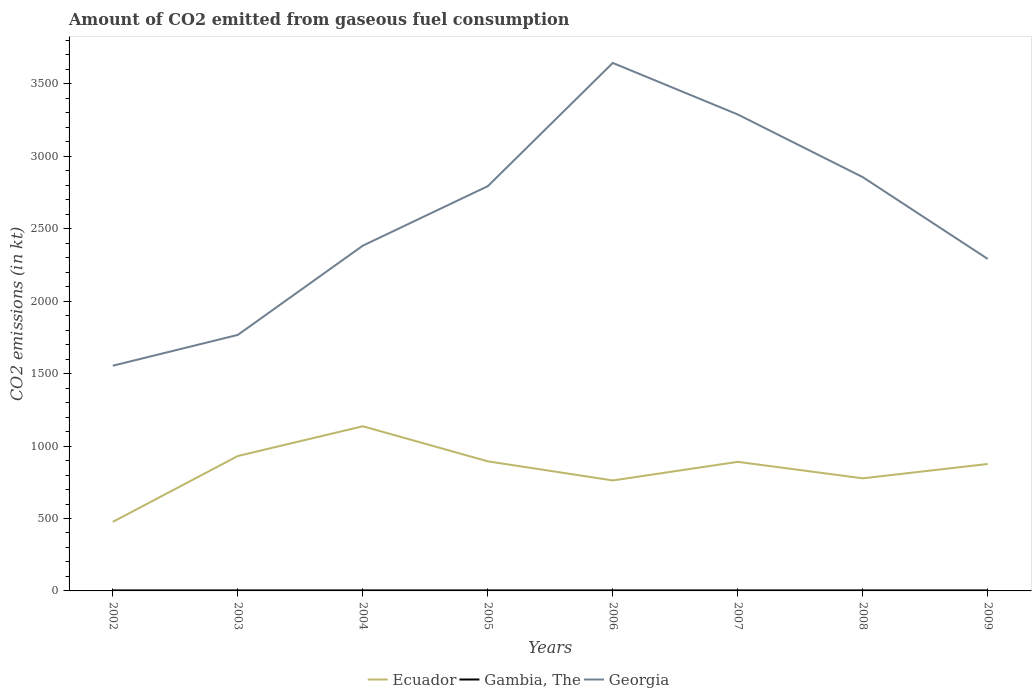How many different coloured lines are there?
Offer a very short reply. 3. Is the number of lines equal to the number of legend labels?
Make the answer very short. Yes. Across all years, what is the maximum amount of CO2 emitted in Gambia, The?
Offer a terse response. 3.67. What is the total amount of CO2 emitted in Ecuador in the graph?
Your response must be concise. 154.01. What is the difference between the highest and the second highest amount of CO2 emitted in Georgia?
Provide a succinct answer. 2090.19. How many lines are there?
Offer a terse response. 3. How many years are there in the graph?
Provide a short and direct response. 8. What is the difference between two consecutive major ticks on the Y-axis?
Your answer should be very brief. 500. Does the graph contain any zero values?
Make the answer very short. No. Where does the legend appear in the graph?
Give a very brief answer. Bottom center. What is the title of the graph?
Provide a short and direct response. Amount of CO2 emitted from gaseous fuel consumption. What is the label or title of the X-axis?
Keep it short and to the point. Years. What is the label or title of the Y-axis?
Your answer should be compact. CO2 emissions (in kt). What is the CO2 emissions (in kt) in Ecuador in 2002?
Give a very brief answer. 476.71. What is the CO2 emissions (in kt) of Gambia, The in 2002?
Give a very brief answer. 3.67. What is the CO2 emissions (in kt) of Georgia in 2002?
Offer a terse response. 1554.81. What is the CO2 emissions (in kt) in Ecuador in 2003?
Offer a very short reply. 931.42. What is the CO2 emissions (in kt) in Gambia, The in 2003?
Make the answer very short. 3.67. What is the CO2 emissions (in kt) of Georgia in 2003?
Provide a short and direct response. 1767.49. What is the CO2 emissions (in kt) in Ecuador in 2004?
Make the answer very short. 1136.77. What is the CO2 emissions (in kt) of Gambia, The in 2004?
Give a very brief answer. 3.67. What is the CO2 emissions (in kt) in Georgia in 2004?
Keep it short and to the point. 2383.55. What is the CO2 emissions (in kt) of Ecuador in 2005?
Provide a succinct answer. 894.75. What is the CO2 emissions (in kt) of Gambia, The in 2005?
Provide a short and direct response. 3.67. What is the CO2 emissions (in kt) in Georgia in 2005?
Offer a terse response. 2794.25. What is the CO2 emissions (in kt) of Ecuador in 2006?
Offer a terse response. 762.74. What is the CO2 emissions (in kt) in Gambia, The in 2006?
Offer a terse response. 3.67. What is the CO2 emissions (in kt) in Georgia in 2006?
Offer a terse response. 3645. What is the CO2 emissions (in kt) of Ecuador in 2007?
Provide a short and direct response. 891.08. What is the CO2 emissions (in kt) of Gambia, The in 2007?
Make the answer very short. 3.67. What is the CO2 emissions (in kt) in Georgia in 2007?
Provide a short and direct response. 3289.3. What is the CO2 emissions (in kt) in Ecuador in 2008?
Keep it short and to the point. 777.4. What is the CO2 emissions (in kt) of Gambia, The in 2008?
Offer a terse response. 3.67. What is the CO2 emissions (in kt) of Georgia in 2008?
Give a very brief answer. 2856.59. What is the CO2 emissions (in kt) in Ecuador in 2009?
Give a very brief answer. 876.41. What is the CO2 emissions (in kt) of Gambia, The in 2009?
Offer a terse response. 3.67. What is the CO2 emissions (in kt) in Georgia in 2009?
Give a very brief answer. 2291.88. Across all years, what is the maximum CO2 emissions (in kt) in Ecuador?
Offer a very short reply. 1136.77. Across all years, what is the maximum CO2 emissions (in kt) of Gambia, The?
Ensure brevity in your answer.  3.67. Across all years, what is the maximum CO2 emissions (in kt) of Georgia?
Make the answer very short. 3645. Across all years, what is the minimum CO2 emissions (in kt) in Ecuador?
Your response must be concise. 476.71. Across all years, what is the minimum CO2 emissions (in kt) of Gambia, The?
Keep it short and to the point. 3.67. Across all years, what is the minimum CO2 emissions (in kt) of Georgia?
Ensure brevity in your answer.  1554.81. What is the total CO2 emissions (in kt) in Ecuador in the graph?
Offer a very short reply. 6747.28. What is the total CO2 emissions (in kt) in Gambia, The in the graph?
Make the answer very short. 29.34. What is the total CO2 emissions (in kt) of Georgia in the graph?
Keep it short and to the point. 2.06e+04. What is the difference between the CO2 emissions (in kt) of Ecuador in 2002 and that in 2003?
Offer a very short reply. -454.71. What is the difference between the CO2 emissions (in kt) in Gambia, The in 2002 and that in 2003?
Your answer should be compact. 0. What is the difference between the CO2 emissions (in kt) of Georgia in 2002 and that in 2003?
Provide a short and direct response. -212.69. What is the difference between the CO2 emissions (in kt) of Ecuador in 2002 and that in 2004?
Your answer should be compact. -660.06. What is the difference between the CO2 emissions (in kt) of Georgia in 2002 and that in 2004?
Give a very brief answer. -828.74. What is the difference between the CO2 emissions (in kt) of Ecuador in 2002 and that in 2005?
Ensure brevity in your answer.  -418.04. What is the difference between the CO2 emissions (in kt) in Gambia, The in 2002 and that in 2005?
Make the answer very short. 0. What is the difference between the CO2 emissions (in kt) of Georgia in 2002 and that in 2005?
Offer a terse response. -1239.45. What is the difference between the CO2 emissions (in kt) of Ecuador in 2002 and that in 2006?
Provide a short and direct response. -286.03. What is the difference between the CO2 emissions (in kt) of Georgia in 2002 and that in 2006?
Your answer should be very brief. -2090.19. What is the difference between the CO2 emissions (in kt) in Ecuador in 2002 and that in 2007?
Your response must be concise. -414.37. What is the difference between the CO2 emissions (in kt) in Georgia in 2002 and that in 2007?
Your response must be concise. -1734.49. What is the difference between the CO2 emissions (in kt) of Ecuador in 2002 and that in 2008?
Your response must be concise. -300.69. What is the difference between the CO2 emissions (in kt) in Gambia, The in 2002 and that in 2008?
Offer a very short reply. 0. What is the difference between the CO2 emissions (in kt) of Georgia in 2002 and that in 2008?
Your response must be concise. -1301.79. What is the difference between the CO2 emissions (in kt) in Ecuador in 2002 and that in 2009?
Offer a terse response. -399.7. What is the difference between the CO2 emissions (in kt) of Georgia in 2002 and that in 2009?
Offer a terse response. -737.07. What is the difference between the CO2 emissions (in kt) in Ecuador in 2003 and that in 2004?
Offer a very short reply. -205.35. What is the difference between the CO2 emissions (in kt) of Gambia, The in 2003 and that in 2004?
Provide a short and direct response. 0. What is the difference between the CO2 emissions (in kt) in Georgia in 2003 and that in 2004?
Your answer should be very brief. -616.06. What is the difference between the CO2 emissions (in kt) of Ecuador in 2003 and that in 2005?
Provide a succinct answer. 36.67. What is the difference between the CO2 emissions (in kt) of Gambia, The in 2003 and that in 2005?
Provide a short and direct response. 0. What is the difference between the CO2 emissions (in kt) of Georgia in 2003 and that in 2005?
Your answer should be very brief. -1026.76. What is the difference between the CO2 emissions (in kt) of Ecuador in 2003 and that in 2006?
Offer a terse response. 168.68. What is the difference between the CO2 emissions (in kt) in Georgia in 2003 and that in 2006?
Your response must be concise. -1877.5. What is the difference between the CO2 emissions (in kt) of Ecuador in 2003 and that in 2007?
Offer a terse response. 40.34. What is the difference between the CO2 emissions (in kt) of Georgia in 2003 and that in 2007?
Your response must be concise. -1521.81. What is the difference between the CO2 emissions (in kt) in Ecuador in 2003 and that in 2008?
Your response must be concise. 154.01. What is the difference between the CO2 emissions (in kt) in Gambia, The in 2003 and that in 2008?
Give a very brief answer. 0. What is the difference between the CO2 emissions (in kt) of Georgia in 2003 and that in 2008?
Offer a very short reply. -1089.1. What is the difference between the CO2 emissions (in kt) of Ecuador in 2003 and that in 2009?
Your answer should be compact. 55.01. What is the difference between the CO2 emissions (in kt) in Georgia in 2003 and that in 2009?
Your answer should be compact. -524.38. What is the difference between the CO2 emissions (in kt) in Ecuador in 2004 and that in 2005?
Your answer should be compact. 242.02. What is the difference between the CO2 emissions (in kt) in Georgia in 2004 and that in 2005?
Offer a very short reply. -410.7. What is the difference between the CO2 emissions (in kt) of Ecuador in 2004 and that in 2006?
Keep it short and to the point. 374.03. What is the difference between the CO2 emissions (in kt) of Gambia, The in 2004 and that in 2006?
Give a very brief answer. 0. What is the difference between the CO2 emissions (in kt) of Georgia in 2004 and that in 2006?
Provide a succinct answer. -1261.45. What is the difference between the CO2 emissions (in kt) of Ecuador in 2004 and that in 2007?
Make the answer very short. 245.69. What is the difference between the CO2 emissions (in kt) of Gambia, The in 2004 and that in 2007?
Give a very brief answer. 0. What is the difference between the CO2 emissions (in kt) of Georgia in 2004 and that in 2007?
Make the answer very short. -905.75. What is the difference between the CO2 emissions (in kt) in Ecuador in 2004 and that in 2008?
Provide a succinct answer. 359.37. What is the difference between the CO2 emissions (in kt) in Georgia in 2004 and that in 2008?
Offer a very short reply. -473.04. What is the difference between the CO2 emissions (in kt) in Ecuador in 2004 and that in 2009?
Offer a terse response. 260.36. What is the difference between the CO2 emissions (in kt) in Gambia, The in 2004 and that in 2009?
Give a very brief answer. 0. What is the difference between the CO2 emissions (in kt) in Georgia in 2004 and that in 2009?
Your response must be concise. 91.67. What is the difference between the CO2 emissions (in kt) of Ecuador in 2005 and that in 2006?
Offer a very short reply. 132.01. What is the difference between the CO2 emissions (in kt) in Georgia in 2005 and that in 2006?
Offer a very short reply. -850.74. What is the difference between the CO2 emissions (in kt) of Ecuador in 2005 and that in 2007?
Offer a terse response. 3.67. What is the difference between the CO2 emissions (in kt) in Georgia in 2005 and that in 2007?
Your response must be concise. -495.05. What is the difference between the CO2 emissions (in kt) in Ecuador in 2005 and that in 2008?
Your answer should be compact. 117.34. What is the difference between the CO2 emissions (in kt) in Georgia in 2005 and that in 2008?
Your response must be concise. -62.34. What is the difference between the CO2 emissions (in kt) of Ecuador in 2005 and that in 2009?
Offer a terse response. 18.34. What is the difference between the CO2 emissions (in kt) of Gambia, The in 2005 and that in 2009?
Ensure brevity in your answer.  0. What is the difference between the CO2 emissions (in kt) in Georgia in 2005 and that in 2009?
Provide a succinct answer. 502.38. What is the difference between the CO2 emissions (in kt) of Ecuador in 2006 and that in 2007?
Make the answer very short. -128.34. What is the difference between the CO2 emissions (in kt) in Georgia in 2006 and that in 2007?
Give a very brief answer. 355.7. What is the difference between the CO2 emissions (in kt) of Ecuador in 2006 and that in 2008?
Offer a terse response. -14.67. What is the difference between the CO2 emissions (in kt) in Georgia in 2006 and that in 2008?
Offer a terse response. 788.4. What is the difference between the CO2 emissions (in kt) of Ecuador in 2006 and that in 2009?
Your answer should be very brief. -113.68. What is the difference between the CO2 emissions (in kt) of Gambia, The in 2006 and that in 2009?
Offer a very short reply. 0. What is the difference between the CO2 emissions (in kt) in Georgia in 2006 and that in 2009?
Offer a terse response. 1353.12. What is the difference between the CO2 emissions (in kt) of Ecuador in 2007 and that in 2008?
Keep it short and to the point. 113.68. What is the difference between the CO2 emissions (in kt) in Georgia in 2007 and that in 2008?
Ensure brevity in your answer.  432.71. What is the difference between the CO2 emissions (in kt) of Ecuador in 2007 and that in 2009?
Provide a succinct answer. 14.67. What is the difference between the CO2 emissions (in kt) in Georgia in 2007 and that in 2009?
Provide a short and direct response. 997.42. What is the difference between the CO2 emissions (in kt) of Ecuador in 2008 and that in 2009?
Offer a terse response. -99.01. What is the difference between the CO2 emissions (in kt) of Georgia in 2008 and that in 2009?
Offer a very short reply. 564.72. What is the difference between the CO2 emissions (in kt) in Ecuador in 2002 and the CO2 emissions (in kt) in Gambia, The in 2003?
Offer a terse response. 473.04. What is the difference between the CO2 emissions (in kt) of Ecuador in 2002 and the CO2 emissions (in kt) of Georgia in 2003?
Keep it short and to the point. -1290.78. What is the difference between the CO2 emissions (in kt) in Gambia, The in 2002 and the CO2 emissions (in kt) in Georgia in 2003?
Your answer should be very brief. -1763.83. What is the difference between the CO2 emissions (in kt) in Ecuador in 2002 and the CO2 emissions (in kt) in Gambia, The in 2004?
Offer a terse response. 473.04. What is the difference between the CO2 emissions (in kt) in Ecuador in 2002 and the CO2 emissions (in kt) in Georgia in 2004?
Make the answer very short. -1906.84. What is the difference between the CO2 emissions (in kt) in Gambia, The in 2002 and the CO2 emissions (in kt) in Georgia in 2004?
Your answer should be very brief. -2379.88. What is the difference between the CO2 emissions (in kt) in Ecuador in 2002 and the CO2 emissions (in kt) in Gambia, The in 2005?
Give a very brief answer. 473.04. What is the difference between the CO2 emissions (in kt) of Ecuador in 2002 and the CO2 emissions (in kt) of Georgia in 2005?
Provide a short and direct response. -2317.54. What is the difference between the CO2 emissions (in kt) in Gambia, The in 2002 and the CO2 emissions (in kt) in Georgia in 2005?
Your answer should be compact. -2790.59. What is the difference between the CO2 emissions (in kt) in Ecuador in 2002 and the CO2 emissions (in kt) in Gambia, The in 2006?
Make the answer very short. 473.04. What is the difference between the CO2 emissions (in kt) of Ecuador in 2002 and the CO2 emissions (in kt) of Georgia in 2006?
Your response must be concise. -3168.29. What is the difference between the CO2 emissions (in kt) in Gambia, The in 2002 and the CO2 emissions (in kt) in Georgia in 2006?
Your answer should be compact. -3641.33. What is the difference between the CO2 emissions (in kt) of Ecuador in 2002 and the CO2 emissions (in kt) of Gambia, The in 2007?
Offer a very short reply. 473.04. What is the difference between the CO2 emissions (in kt) of Ecuador in 2002 and the CO2 emissions (in kt) of Georgia in 2007?
Your answer should be compact. -2812.59. What is the difference between the CO2 emissions (in kt) of Gambia, The in 2002 and the CO2 emissions (in kt) of Georgia in 2007?
Your response must be concise. -3285.63. What is the difference between the CO2 emissions (in kt) in Ecuador in 2002 and the CO2 emissions (in kt) in Gambia, The in 2008?
Offer a terse response. 473.04. What is the difference between the CO2 emissions (in kt) in Ecuador in 2002 and the CO2 emissions (in kt) in Georgia in 2008?
Offer a very short reply. -2379.88. What is the difference between the CO2 emissions (in kt) of Gambia, The in 2002 and the CO2 emissions (in kt) of Georgia in 2008?
Provide a short and direct response. -2852.93. What is the difference between the CO2 emissions (in kt) of Ecuador in 2002 and the CO2 emissions (in kt) of Gambia, The in 2009?
Ensure brevity in your answer.  473.04. What is the difference between the CO2 emissions (in kt) of Ecuador in 2002 and the CO2 emissions (in kt) of Georgia in 2009?
Offer a terse response. -1815.16. What is the difference between the CO2 emissions (in kt) of Gambia, The in 2002 and the CO2 emissions (in kt) of Georgia in 2009?
Give a very brief answer. -2288.21. What is the difference between the CO2 emissions (in kt) in Ecuador in 2003 and the CO2 emissions (in kt) in Gambia, The in 2004?
Provide a succinct answer. 927.75. What is the difference between the CO2 emissions (in kt) of Ecuador in 2003 and the CO2 emissions (in kt) of Georgia in 2004?
Give a very brief answer. -1452.13. What is the difference between the CO2 emissions (in kt) of Gambia, The in 2003 and the CO2 emissions (in kt) of Georgia in 2004?
Offer a very short reply. -2379.88. What is the difference between the CO2 emissions (in kt) of Ecuador in 2003 and the CO2 emissions (in kt) of Gambia, The in 2005?
Your answer should be very brief. 927.75. What is the difference between the CO2 emissions (in kt) of Ecuador in 2003 and the CO2 emissions (in kt) of Georgia in 2005?
Give a very brief answer. -1862.84. What is the difference between the CO2 emissions (in kt) of Gambia, The in 2003 and the CO2 emissions (in kt) of Georgia in 2005?
Make the answer very short. -2790.59. What is the difference between the CO2 emissions (in kt) of Ecuador in 2003 and the CO2 emissions (in kt) of Gambia, The in 2006?
Ensure brevity in your answer.  927.75. What is the difference between the CO2 emissions (in kt) in Ecuador in 2003 and the CO2 emissions (in kt) in Georgia in 2006?
Give a very brief answer. -2713.58. What is the difference between the CO2 emissions (in kt) of Gambia, The in 2003 and the CO2 emissions (in kt) of Georgia in 2006?
Your response must be concise. -3641.33. What is the difference between the CO2 emissions (in kt) in Ecuador in 2003 and the CO2 emissions (in kt) in Gambia, The in 2007?
Keep it short and to the point. 927.75. What is the difference between the CO2 emissions (in kt) of Ecuador in 2003 and the CO2 emissions (in kt) of Georgia in 2007?
Your answer should be very brief. -2357.88. What is the difference between the CO2 emissions (in kt) in Gambia, The in 2003 and the CO2 emissions (in kt) in Georgia in 2007?
Your response must be concise. -3285.63. What is the difference between the CO2 emissions (in kt) in Ecuador in 2003 and the CO2 emissions (in kt) in Gambia, The in 2008?
Make the answer very short. 927.75. What is the difference between the CO2 emissions (in kt) in Ecuador in 2003 and the CO2 emissions (in kt) in Georgia in 2008?
Offer a terse response. -1925.17. What is the difference between the CO2 emissions (in kt) of Gambia, The in 2003 and the CO2 emissions (in kt) of Georgia in 2008?
Make the answer very short. -2852.93. What is the difference between the CO2 emissions (in kt) of Ecuador in 2003 and the CO2 emissions (in kt) of Gambia, The in 2009?
Keep it short and to the point. 927.75. What is the difference between the CO2 emissions (in kt) of Ecuador in 2003 and the CO2 emissions (in kt) of Georgia in 2009?
Your response must be concise. -1360.46. What is the difference between the CO2 emissions (in kt) of Gambia, The in 2003 and the CO2 emissions (in kt) of Georgia in 2009?
Your answer should be very brief. -2288.21. What is the difference between the CO2 emissions (in kt) of Ecuador in 2004 and the CO2 emissions (in kt) of Gambia, The in 2005?
Provide a succinct answer. 1133.1. What is the difference between the CO2 emissions (in kt) in Ecuador in 2004 and the CO2 emissions (in kt) in Georgia in 2005?
Offer a terse response. -1657.48. What is the difference between the CO2 emissions (in kt) in Gambia, The in 2004 and the CO2 emissions (in kt) in Georgia in 2005?
Offer a terse response. -2790.59. What is the difference between the CO2 emissions (in kt) of Ecuador in 2004 and the CO2 emissions (in kt) of Gambia, The in 2006?
Your response must be concise. 1133.1. What is the difference between the CO2 emissions (in kt) of Ecuador in 2004 and the CO2 emissions (in kt) of Georgia in 2006?
Your answer should be very brief. -2508.23. What is the difference between the CO2 emissions (in kt) of Gambia, The in 2004 and the CO2 emissions (in kt) of Georgia in 2006?
Provide a short and direct response. -3641.33. What is the difference between the CO2 emissions (in kt) of Ecuador in 2004 and the CO2 emissions (in kt) of Gambia, The in 2007?
Make the answer very short. 1133.1. What is the difference between the CO2 emissions (in kt) in Ecuador in 2004 and the CO2 emissions (in kt) in Georgia in 2007?
Provide a succinct answer. -2152.53. What is the difference between the CO2 emissions (in kt) of Gambia, The in 2004 and the CO2 emissions (in kt) of Georgia in 2007?
Your answer should be very brief. -3285.63. What is the difference between the CO2 emissions (in kt) in Ecuador in 2004 and the CO2 emissions (in kt) in Gambia, The in 2008?
Provide a succinct answer. 1133.1. What is the difference between the CO2 emissions (in kt) of Ecuador in 2004 and the CO2 emissions (in kt) of Georgia in 2008?
Keep it short and to the point. -1719.82. What is the difference between the CO2 emissions (in kt) of Gambia, The in 2004 and the CO2 emissions (in kt) of Georgia in 2008?
Provide a short and direct response. -2852.93. What is the difference between the CO2 emissions (in kt) in Ecuador in 2004 and the CO2 emissions (in kt) in Gambia, The in 2009?
Give a very brief answer. 1133.1. What is the difference between the CO2 emissions (in kt) in Ecuador in 2004 and the CO2 emissions (in kt) in Georgia in 2009?
Your answer should be compact. -1155.11. What is the difference between the CO2 emissions (in kt) of Gambia, The in 2004 and the CO2 emissions (in kt) of Georgia in 2009?
Provide a short and direct response. -2288.21. What is the difference between the CO2 emissions (in kt) of Ecuador in 2005 and the CO2 emissions (in kt) of Gambia, The in 2006?
Make the answer very short. 891.08. What is the difference between the CO2 emissions (in kt) in Ecuador in 2005 and the CO2 emissions (in kt) in Georgia in 2006?
Your answer should be very brief. -2750.25. What is the difference between the CO2 emissions (in kt) of Gambia, The in 2005 and the CO2 emissions (in kt) of Georgia in 2006?
Provide a short and direct response. -3641.33. What is the difference between the CO2 emissions (in kt) in Ecuador in 2005 and the CO2 emissions (in kt) in Gambia, The in 2007?
Offer a terse response. 891.08. What is the difference between the CO2 emissions (in kt) of Ecuador in 2005 and the CO2 emissions (in kt) of Georgia in 2007?
Offer a terse response. -2394.55. What is the difference between the CO2 emissions (in kt) of Gambia, The in 2005 and the CO2 emissions (in kt) of Georgia in 2007?
Your answer should be compact. -3285.63. What is the difference between the CO2 emissions (in kt) of Ecuador in 2005 and the CO2 emissions (in kt) of Gambia, The in 2008?
Your answer should be very brief. 891.08. What is the difference between the CO2 emissions (in kt) in Ecuador in 2005 and the CO2 emissions (in kt) in Georgia in 2008?
Offer a terse response. -1961.85. What is the difference between the CO2 emissions (in kt) in Gambia, The in 2005 and the CO2 emissions (in kt) in Georgia in 2008?
Offer a very short reply. -2852.93. What is the difference between the CO2 emissions (in kt) in Ecuador in 2005 and the CO2 emissions (in kt) in Gambia, The in 2009?
Keep it short and to the point. 891.08. What is the difference between the CO2 emissions (in kt) in Ecuador in 2005 and the CO2 emissions (in kt) in Georgia in 2009?
Make the answer very short. -1397.13. What is the difference between the CO2 emissions (in kt) in Gambia, The in 2005 and the CO2 emissions (in kt) in Georgia in 2009?
Give a very brief answer. -2288.21. What is the difference between the CO2 emissions (in kt) of Ecuador in 2006 and the CO2 emissions (in kt) of Gambia, The in 2007?
Your answer should be compact. 759.07. What is the difference between the CO2 emissions (in kt) in Ecuador in 2006 and the CO2 emissions (in kt) in Georgia in 2007?
Make the answer very short. -2526.56. What is the difference between the CO2 emissions (in kt) of Gambia, The in 2006 and the CO2 emissions (in kt) of Georgia in 2007?
Your answer should be compact. -3285.63. What is the difference between the CO2 emissions (in kt) of Ecuador in 2006 and the CO2 emissions (in kt) of Gambia, The in 2008?
Give a very brief answer. 759.07. What is the difference between the CO2 emissions (in kt) of Ecuador in 2006 and the CO2 emissions (in kt) of Georgia in 2008?
Provide a succinct answer. -2093.86. What is the difference between the CO2 emissions (in kt) in Gambia, The in 2006 and the CO2 emissions (in kt) in Georgia in 2008?
Your response must be concise. -2852.93. What is the difference between the CO2 emissions (in kt) of Ecuador in 2006 and the CO2 emissions (in kt) of Gambia, The in 2009?
Your answer should be very brief. 759.07. What is the difference between the CO2 emissions (in kt) of Ecuador in 2006 and the CO2 emissions (in kt) of Georgia in 2009?
Offer a terse response. -1529.14. What is the difference between the CO2 emissions (in kt) in Gambia, The in 2006 and the CO2 emissions (in kt) in Georgia in 2009?
Keep it short and to the point. -2288.21. What is the difference between the CO2 emissions (in kt) of Ecuador in 2007 and the CO2 emissions (in kt) of Gambia, The in 2008?
Keep it short and to the point. 887.41. What is the difference between the CO2 emissions (in kt) of Ecuador in 2007 and the CO2 emissions (in kt) of Georgia in 2008?
Provide a succinct answer. -1965.51. What is the difference between the CO2 emissions (in kt) of Gambia, The in 2007 and the CO2 emissions (in kt) of Georgia in 2008?
Keep it short and to the point. -2852.93. What is the difference between the CO2 emissions (in kt) of Ecuador in 2007 and the CO2 emissions (in kt) of Gambia, The in 2009?
Your answer should be compact. 887.41. What is the difference between the CO2 emissions (in kt) of Ecuador in 2007 and the CO2 emissions (in kt) of Georgia in 2009?
Keep it short and to the point. -1400.79. What is the difference between the CO2 emissions (in kt) of Gambia, The in 2007 and the CO2 emissions (in kt) of Georgia in 2009?
Provide a short and direct response. -2288.21. What is the difference between the CO2 emissions (in kt) in Ecuador in 2008 and the CO2 emissions (in kt) in Gambia, The in 2009?
Give a very brief answer. 773.74. What is the difference between the CO2 emissions (in kt) of Ecuador in 2008 and the CO2 emissions (in kt) of Georgia in 2009?
Provide a succinct answer. -1514.47. What is the difference between the CO2 emissions (in kt) in Gambia, The in 2008 and the CO2 emissions (in kt) in Georgia in 2009?
Keep it short and to the point. -2288.21. What is the average CO2 emissions (in kt) in Ecuador per year?
Keep it short and to the point. 843.41. What is the average CO2 emissions (in kt) of Gambia, The per year?
Keep it short and to the point. 3.67. What is the average CO2 emissions (in kt) in Georgia per year?
Keep it short and to the point. 2572.86. In the year 2002, what is the difference between the CO2 emissions (in kt) in Ecuador and CO2 emissions (in kt) in Gambia, The?
Provide a short and direct response. 473.04. In the year 2002, what is the difference between the CO2 emissions (in kt) of Ecuador and CO2 emissions (in kt) of Georgia?
Provide a succinct answer. -1078.1. In the year 2002, what is the difference between the CO2 emissions (in kt) in Gambia, The and CO2 emissions (in kt) in Georgia?
Ensure brevity in your answer.  -1551.14. In the year 2003, what is the difference between the CO2 emissions (in kt) of Ecuador and CO2 emissions (in kt) of Gambia, The?
Your answer should be very brief. 927.75. In the year 2003, what is the difference between the CO2 emissions (in kt) in Ecuador and CO2 emissions (in kt) in Georgia?
Provide a short and direct response. -836.08. In the year 2003, what is the difference between the CO2 emissions (in kt) of Gambia, The and CO2 emissions (in kt) of Georgia?
Ensure brevity in your answer.  -1763.83. In the year 2004, what is the difference between the CO2 emissions (in kt) of Ecuador and CO2 emissions (in kt) of Gambia, The?
Your answer should be very brief. 1133.1. In the year 2004, what is the difference between the CO2 emissions (in kt) in Ecuador and CO2 emissions (in kt) in Georgia?
Your answer should be very brief. -1246.78. In the year 2004, what is the difference between the CO2 emissions (in kt) in Gambia, The and CO2 emissions (in kt) in Georgia?
Your answer should be compact. -2379.88. In the year 2005, what is the difference between the CO2 emissions (in kt) of Ecuador and CO2 emissions (in kt) of Gambia, The?
Your answer should be compact. 891.08. In the year 2005, what is the difference between the CO2 emissions (in kt) in Ecuador and CO2 emissions (in kt) in Georgia?
Give a very brief answer. -1899.51. In the year 2005, what is the difference between the CO2 emissions (in kt) of Gambia, The and CO2 emissions (in kt) of Georgia?
Ensure brevity in your answer.  -2790.59. In the year 2006, what is the difference between the CO2 emissions (in kt) of Ecuador and CO2 emissions (in kt) of Gambia, The?
Provide a short and direct response. 759.07. In the year 2006, what is the difference between the CO2 emissions (in kt) of Ecuador and CO2 emissions (in kt) of Georgia?
Your answer should be compact. -2882.26. In the year 2006, what is the difference between the CO2 emissions (in kt) in Gambia, The and CO2 emissions (in kt) in Georgia?
Your response must be concise. -3641.33. In the year 2007, what is the difference between the CO2 emissions (in kt) of Ecuador and CO2 emissions (in kt) of Gambia, The?
Provide a succinct answer. 887.41. In the year 2007, what is the difference between the CO2 emissions (in kt) of Ecuador and CO2 emissions (in kt) of Georgia?
Your answer should be very brief. -2398.22. In the year 2007, what is the difference between the CO2 emissions (in kt) of Gambia, The and CO2 emissions (in kt) of Georgia?
Provide a short and direct response. -3285.63. In the year 2008, what is the difference between the CO2 emissions (in kt) of Ecuador and CO2 emissions (in kt) of Gambia, The?
Keep it short and to the point. 773.74. In the year 2008, what is the difference between the CO2 emissions (in kt) of Ecuador and CO2 emissions (in kt) of Georgia?
Provide a short and direct response. -2079.19. In the year 2008, what is the difference between the CO2 emissions (in kt) of Gambia, The and CO2 emissions (in kt) of Georgia?
Provide a short and direct response. -2852.93. In the year 2009, what is the difference between the CO2 emissions (in kt) of Ecuador and CO2 emissions (in kt) of Gambia, The?
Ensure brevity in your answer.  872.75. In the year 2009, what is the difference between the CO2 emissions (in kt) of Ecuador and CO2 emissions (in kt) of Georgia?
Ensure brevity in your answer.  -1415.46. In the year 2009, what is the difference between the CO2 emissions (in kt) of Gambia, The and CO2 emissions (in kt) of Georgia?
Make the answer very short. -2288.21. What is the ratio of the CO2 emissions (in kt) in Ecuador in 2002 to that in 2003?
Your answer should be compact. 0.51. What is the ratio of the CO2 emissions (in kt) of Georgia in 2002 to that in 2003?
Provide a succinct answer. 0.88. What is the ratio of the CO2 emissions (in kt) of Ecuador in 2002 to that in 2004?
Provide a short and direct response. 0.42. What is the ratio of the CO2 emissions (in kt) in Gambia, The in 2002 to that in 2004?
Your response must be concise. 1. What is the ratio of the CO2 emissions (in kt) of Georgia in 2002 to that in 2004?
Offer a very short reply. 0.65. What is the ratio of the CO2 emissions (in kt) of Ecuador in 2002 to that in 2005?
Provide a short and direct response. 0.53. What is the ratio of the CO2 emissions (in kt) of Gambia, The in 2002 to that in 2005?
Offer a very short reply. 1. What is the ratio of the CO2 emissions (in kt) of Georgia in 2002 to that in 2005?
Ensure brevity in your answer.  0.56. What is the ratio of the CO2 emissions (in kt) of Gambia, The in 2002 to that in 2006?
Offer a very short reply. 1. What is the ratio of the CO2 emissions (in kt) in Georgia in 2002 to that in 2006?
Keep it short and to the point. 0.43. What is the ratio of the CO2 emissions (in kt) in Ecuador in 2002 to that in 2007?
Your answer should be very brief. 0.54. What is the ratio of the CO2 emissions (in kt) of Georgia in 2002 to that in 2007?
Offer a very short reply. 0.47. What is the ratio of the CO2 emissions (in kt) of Ecuador in 2002 to that in 2008?
Your response must be concise. 0.61. What is the ratio of the CO2 emissions (in kt) in Georgia in 2002 to that in 2008?
Your answer should be compact. 0.54. What is the ratio of the CO2 emissions (in kt) in Ecuador in 2002 to that in 2009?
Give a very brief answer. 0.54. What is the ratio of the CO2 emissions (in kt) of Gambia, The in 2002 to that in 2009?
Provide a short and direct response. 1. What is the ratio of the CO2 emissions (in kt) in Georgia in 2002 to that in 2009?
Offer a terse response. 0.68. What is the ratio of the CO2 emissions (in kt) of Ecuador in 2003 to that in 2004?
Your response must be concise. 0.82. What is the ratio of the CO2 emissions (in kt) of Georgia in 2003 to that in 2004?
Give a very brief answer. 0.74. What is the ratio of the CO2 emissions (in kt) of Ecuador in 2003 to that in 2005?
Provide a succinct answer. 1.04. What is the ratio of the CO2 emissions (in kt) of Gambia, The in 2003 to that in 2005?
Your answer should be compact. 1. What is the ratio of the CO2 emissions (in kt) in Georgia in 2003 to that in 2005?
Give a very brief answer. 0.63. What is the ratio of the CO2 emissions (in kt) of Ecuador in 2003 to that in 2006?
Make the answer very short. 1.22. What is the ratio of the CO2 emissions (in kt) in Gambia, The in 2003 to that in 2006?
Ensure brevity in your answer.  1. What is the ratio of the CO2 emissions (in kt) in Georgia in 2003 to that in 2006?
Offer a terse response. 0.48. What is the ratio of the CO2 emissions (in kt) in Ecuador in 2003 to that in 2007?
Your answer should be compact. 1.05. What is the ratio of the CO2 emissions (in kt) of Gambia, The in 2003 to that in 2007?
Give a very brief answer. 1. What is the ratio of the CO2 emissions (in kt) of Georgia in 2003 to that in 2007?
Provide a short and direct response. 0.54. What is the ratio of the CO2 emissions (in kt) in Ecuador in 2003 to that in 2008?
Offer a terse response. 1.2. What is the ratio of the CO2 emissions (in kt) in Gambia, The in 2003 to that in 2008?
Your answer should be very brief. 1. What is the ratio of the CO2 emissions (in kt) of Georgia in 2003 to that in 2008?
Provide a succinct answer. 0.62. What is the ratio of the CO2 emissions (in kt) in Ecuador in 2003 to that in 2009?
Provide a succinct answer. 1.06. What is the ratio of the CO2 emissions (in kt) of Gambia, The in 2003 to that in 2009?
Your response must be concise. 1. What is the ratio of the CO2 emissions (in kt) in Georgia in 2003 to that in 2009?
Your response must be concise. 0.77. What is the ratio of the CO2 emissions (in kt) of Ecuador in 2004 to that in 2005?
Provide a short and direct response. 1.27. What is the ratio of the CO2 emissions (in kt) of Georgia in 2004 to that in 2005?
Provide a succinct answer. 0.85. What is the ratio of the CO2 emissions (in kt) in Ecuador in 2004 to that in 2006?
Provide a succinct answer. 1.49. What is the ratio of the CO2 emissions (in kt) in Gambia, The in 2004 to that in 2006?
Your answer should be very brief. 1. What is the ratio of the CO2 emissions (in kt) in Georgia in 2004 to that in 2006?
Provide a succinct answer. 0.65. What is the ratio of the CO2 emissions (in kt) of Ecuador in 2004 to that in 2007?
Offer a very short reply. 1.28. What is the ratio of the CO2 emissions (in kt) of Georgia in 2004 to that in 2007?
Your answer should be very brief. 0.72. What is the ratio of the CO2 emissions (in kt) in Ecuador in 2004 to that in 2008?
Provide a succinct answer. 1.46. What is the ratio of the CO2 emissions (in kt) of Georgia in 2004 to that in 2008?
Give a very brief answer. 0.83. What is the ratio of the CO2 emissions (in kt) in Ecuador in 2004 to that in 2009?
Give a very brief answer. 1.3. What is the ratio of the CO2 emissions (in kt) of Gambia, The in 2004 to that in 2009?
Keep it short and to the point. 1. What is the ratio of the CO2 emissions (in kt) in Ecuador in 2005 to that in 2006?
Ensure brevity in your answer.  1.17. What is the ratio of the CO2 emissions (in kt) in Georgia in 2005 to that in 2006?
Provide a succinct answer. 0.77. What is the ratio of the CO2 emissions (in kt) in Ecuador in 2005 to that in 2007?
Keep it short and to the point. 1. What is the ratio of the CO2 emissions (in kt) of Georgia in 2005 to that in 2007?
Make the answer very short. 0.85. What is the ratio of the CO2 emissions (in kt) in Ecuador in 2005 to that in 2008?
Your response must be concise. 1.15. What is the ratio of the CO2 emissions (in kt) in Gambia, The in 2005 to that in 2008?
Give a very brief answer. 1. What is the ratio of the CO2 emissions (in kt) of Georgia in 2005 to that in 2008?
Give a very brief answer. 0.98. What is the ratio of the CO2 emissions (in kt) in Ecuador in 2005 to that in 2009?
Give a very brief answer. 1.02. What is the ratio of the CO2 emissions (in kt) of Gambia, The in 2005 to that in 2009?
Ensure brevity in your answer.  1. What is the ratio of the CO2 emissions (in kt) of Georgia in 2005 to that in 2009?
Provide a succinct answer. 1.22. What is the ratio of the CO2 emissions (in kt) of Ecuador in 2006 to that in 2007?
Your response must be concise. 0.86. What is the ratio of the CO2 emissions (in kt) of Gambia, The in 2006 to that in 2007?
Your answer should be compact. 1. What is the ratio of the CO2 emissions (in kt) of Georgia in 2006 to that in 2007?
Offer a very short reply. 1.11. What is the ratio of the CO2 emissions (in kt) in Ecuador in 2006 to that in 2008?
Offer a terse response. 0.98. What is the ratio of the CO2 emissions (in kt) in Gambia, The in 2006 to that in 2008?
Give a very brief answer. 1. What is the ratio of the CO2 emissions (in kt) in Georgia in 2006 to that in 2008?
Offer a very short reply. 1.28. What is the ratio of the CO2 emissions (in kt) in Ecuador in 2006 to that in 2009?
Your response must be concise. 0.87. What is the ratio of the CO2 emissions (in kt) of Georgia in 2006 to that in 2009?
Ensure brevity in your answer.  1.59. What is the ratio of the CO2 emissions (in kt) of Ecuador in 2007 to that in 2008?
Give a very brief answer. 1.15. What is the ratio of the CO2 emissions (in kt) of Gambia, The in 2007 to that in 2008?
Your response must be concise. 1. What is the ratio of the CO2 emissions (in kt) of Georgia in 2007 to that in 2008?
Keep it short and to the point. 1.15. What is the ratio of the CO2 emissions (in kt) of Ecuador in 2007 to that in 2009?
Offer a terse response. 1.02. What is the ratio of the CO2 emissions (in kt) in Georgia in 2007 to that in 2009?
Make the answer very short. 1.44. What is the ratio of the CO2 emissions (in kt) of Ecuador in 2008 to that in 2009?
Keep it short and to the point. 0.89. What is the ratio of the CO2 emissions (in kt) in Gambia, The in 2008 to that in 2009?
Your answer should be compact. 1. What is the ratio of the CO2 emissions (in kt) in Georgia in 2008 to that in 2009?
Provide a succinct answer. 1.25. What is the difference between the highest and the second highest CO2 emissions (in kt) in Ecuador?
Your response must be concise. 205.35. What is the difference between the highest and the second highest CO2 emissions (in kt) of Georgia?
Ensure brevity in your answer.  355.7. What is the difference between the highest and the lowest CO2 emissions (in kt) of Ecuador?
Make the answer very short. 660.06. What is the difference between the highest and the lowest CO2 emissions (in kt) in Gambia, The?
Your answer should be very brief. 0. What is the difference between the highest and the lowest CO2 emissions (in kt) of Georgia?
Your response must be concise. 2090.19. 